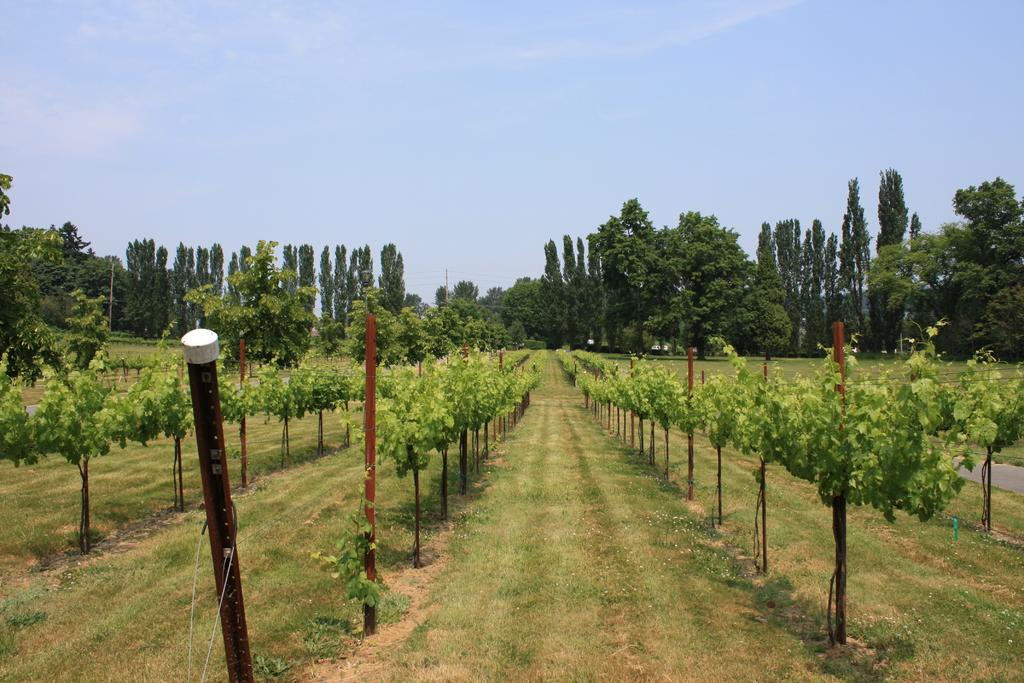What type of vegetation can be seen in the image? There are plants and trees in the image. What else is present in the image besides vegetation? There are poles in the image. What is the condition of the sky in the image? The sky is cloudy in the image. Can you tell me how many monkeys are sitting on the branches of the trees in the image? There are no monkeys present in the image; it features plants, trees, and poles. What type of disease is affecting the plants in the image? There is no indication of any disease affecting the plants in the image. 